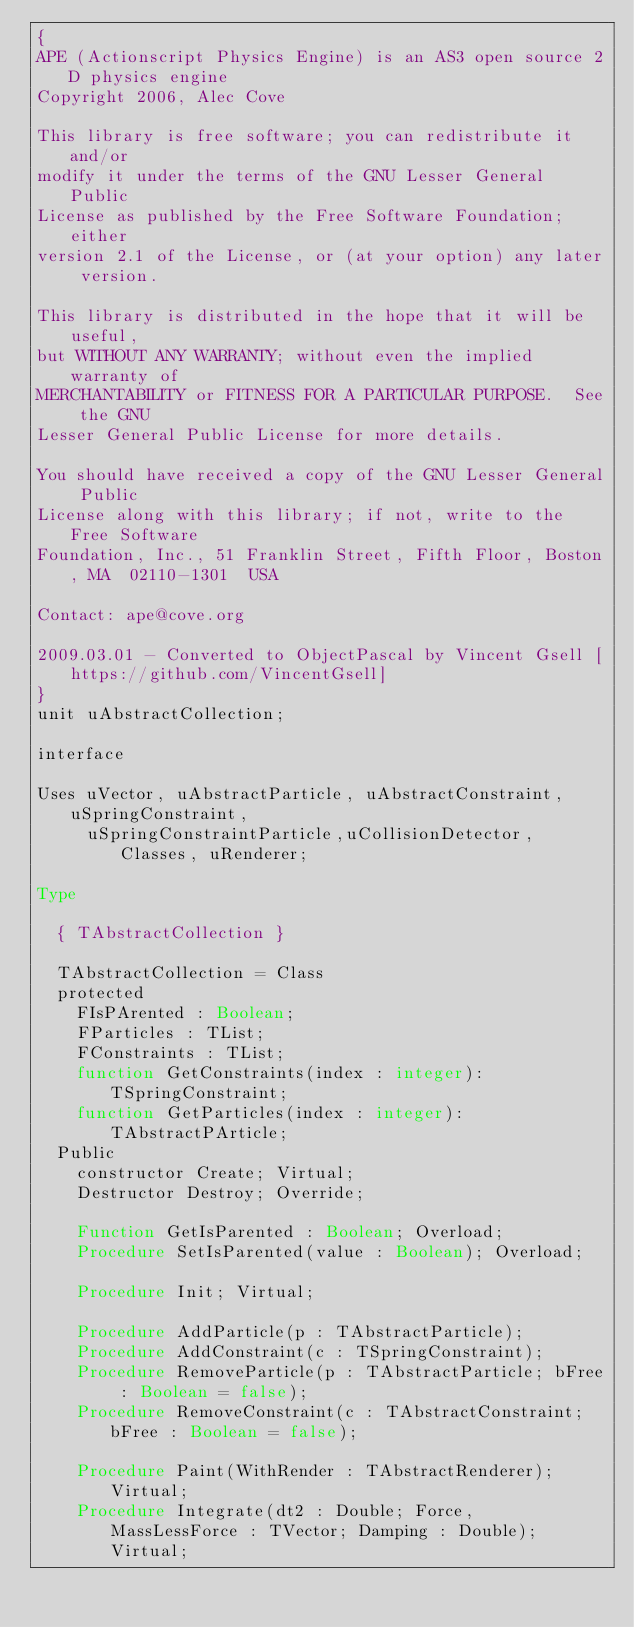<code> <loc_0><loc_0><loc_500><loc_500><_Pascal_>{
APE (Actionscript Physics Engine) is an AS3 open source 2D physics engine
Copyright 2006, Alec Cove

This library is free software; you can redistribute it and/or
modify it under the terms of the GNU Lesser General Public
License as published by the Free Software Foundation; either
version 2.1 of the License, or (at your option) any later version.

This library is distributed in the hope that it will be useful,
but WITHOUT ANY WARRANTY; without even the implied warranty of
MERCHANTABILITY or FITNESS FOR A PARTICULAR PURPOSE.  See the GNU
Lesser General Public License for more details.

You should have received a copy of the GNU Lesser General Public
License along with this library; if not, write to the Free Software
Foundation, Inc., 51 Franklin Street, Fifth Floor, Boston, MA  02110-1301  USA

Contact: ape@cove.org

2009.03.01 - Converted to ObjectPascal by Vincent Gsell [https://github.com/VincentGsell]
}
unit uAbstractCollection;

interface

Uses uVector, uAbstractParticle, uAbstractConstraint, uSpringConstraint,
     uSpringConstraintParticle,uCollisionDetector, Classes, uRenderer;

Type

  { TAbstractCollection }

  TAbstractCollection = Class
  protected
    FIsPArented : Boolean;
    FParticles : TList;
    FConstraints : TList;
    function GetConstraints(index : integer): TSpringConstraint;
    function GetParticles(index : integer): TAbstractPArticle;
  Public
    constructor Create; Virtual;
    Destructor Destroy; Override;

    Function GetIsParented : Boolean; Overload;
    Procedure SetIsParented(value : Boolean); Overload;

    Procedure Init; Virtual;

    Procedure AddParticle(p : TAbstractParticle);
    Procedure AddConstraint(c : TSpringConstraint);
    Procedure RemoveParticle(p : TAbstractParticle; bFree : Boolean = false);
    Procedure RemoveConstraint(c : TAbstractConstraint; bFree : Boolean = false);

    Procedure Paint(WithRender : TAbstractRenderer); Virtual;
    Procedure Integrate(dt2 : Double; Force, MassLessForce : TVector; Damping : Double); Virtual;</code> 